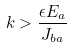Convert formula to latex. <formula><loc_0><loc_0><loc_500><loc_500>k > \frac { \epsilon E _ { a } } { J _ { b a } }</formula> 